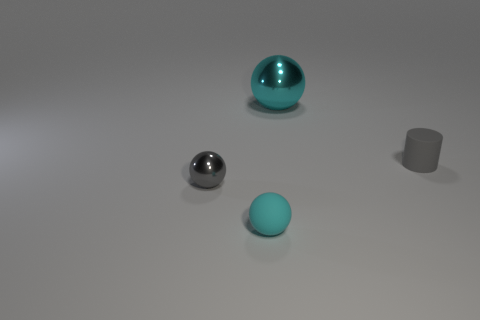Add 3 cyan metal things. How many objects exist? 7 Subtract all spheres. How many objects are left? 1 Subtract 0 brown blocks. How many objects are left? 4 Subtract all big red rubber cylinders. Subtract all large metallic objects. How many objects are left? 3 Add 2 metallic objects. How many metallic objects are left? 4 Add 1 large blue spheres. How many large blue spheres exist? 1 